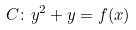<formula> <loc_0><loc_0><loc_500><loc_500>C \colon y ^ { 2 } + y = f ( x )</formula> 